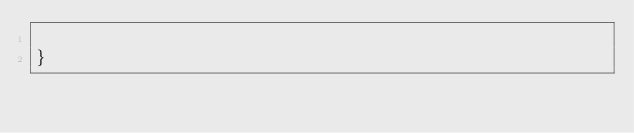Convert code to text. <code><loc_0><loc_0><loc_500><loc_500><_Swift_>
}
</code> 